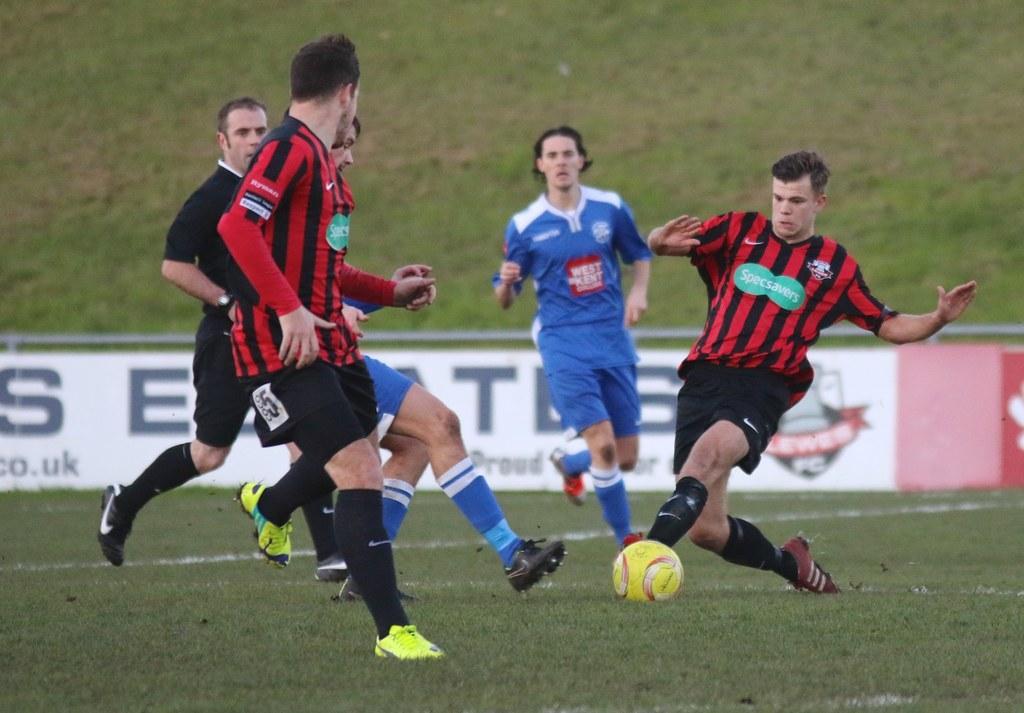In one or two sentences, can you explain what this image depicts? In this image, we can see a group of people are running on the grass. Here there is a ball on the grass. They are playing a game. Background we can see banner. Here we can see a blur view. 